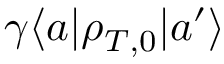Convert formula to latex. <formula><loc_0><loc_0><loc_500><loc_500>\gamma \langle a | \rho _ { T , 0 } | a ^ { \prime } \rangle</formula> 